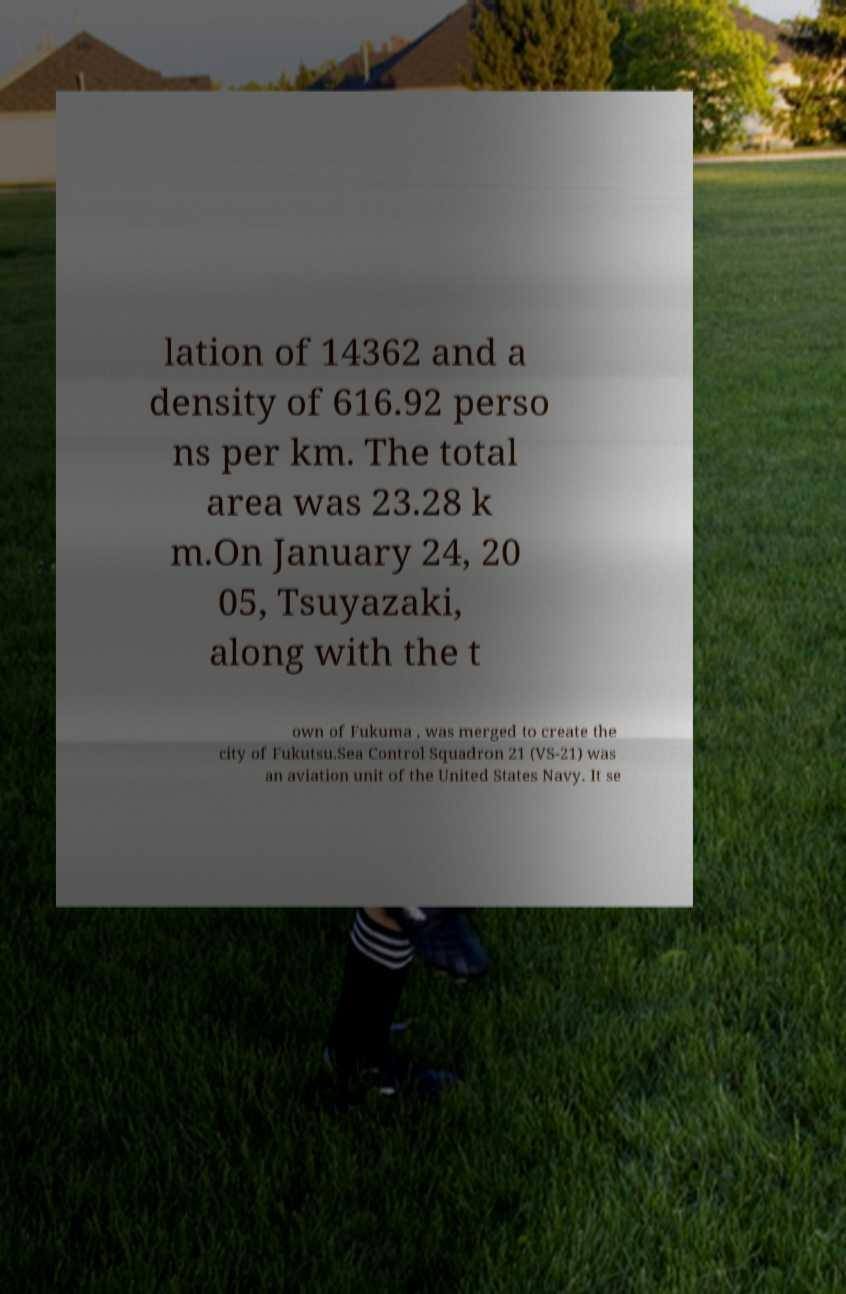I need the written content from this picture converted into text. Can you do that? lation of 14362 and a density of 616.92 perso ns per km. The total area was 23.28 k m.On January 24, 20 05, Tsuyazaki, along with the t own of Fukuma , was merged to create the city of Fukutsu.Sea Control Squadron 21 (VS-21) was an aviation unit of the United States Navy. It se 